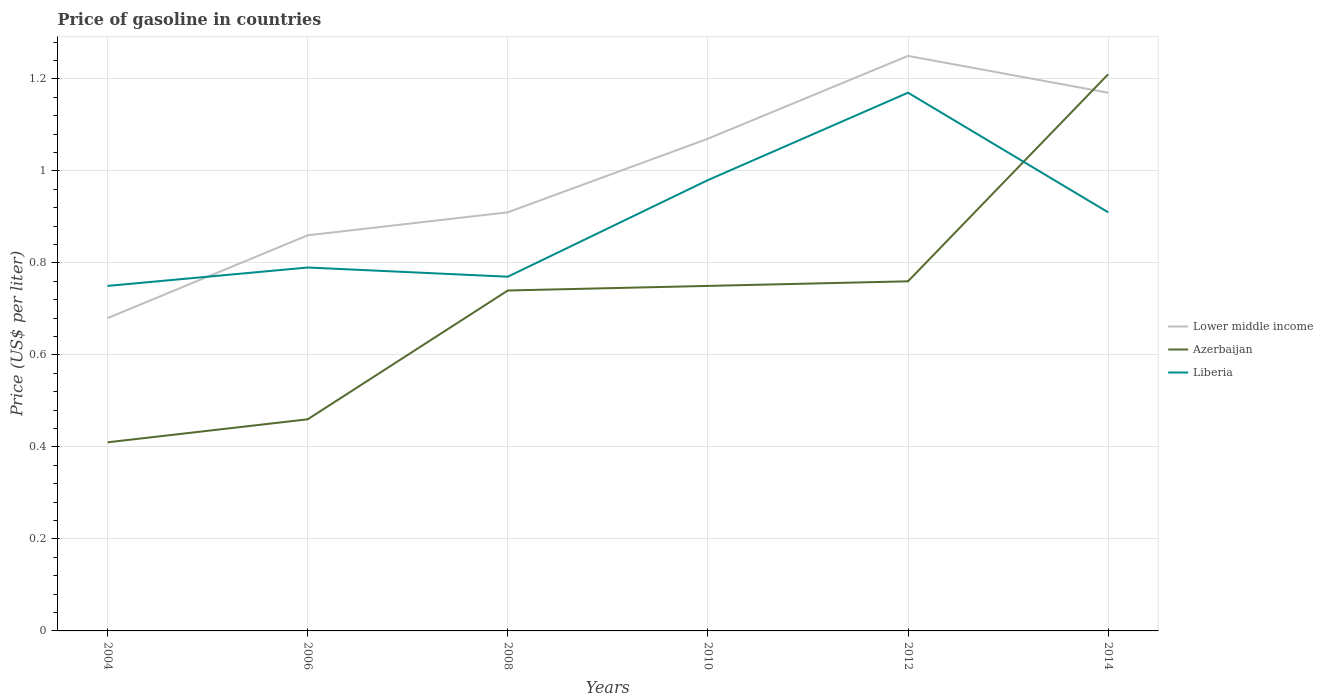Across all years, what is the maximum price of gasoline in Azerbaijan?
Offer a terse response. 0.41. What is the total price of gasoline in Lower middle income in the graph?
Make the answer very short. -0.1. What is the difference between the highest and the second highest price of gasoline in Lower middle income?
Your answer should be compact. 0.57. What is the difference between the highest and the lowest price of gasoline in Azerbaijan?
Make the answer very short. 4. Are the values on the major ticks of Y-axis written in scientific E-notation?
Your answer should be very brief. No. Does the graph contain any zero values?
Your answer should be compact. No. Does the graph contain grids?
Provide a short and direct response. Yes. Where does the legend appear in the graph?
Make the answer very short. Center right. How many legend labels are there?
Your answer should be compact. 3. How are the legend labels stacked?
Make the answer very short. Vertical. What is the title of the graph?
Your response must be concise. Price of gasoline in countries. What is the label or title of the Y-axis?
Offer a very short reply. Price (US$ per liter). What is the Price (US$ per liter) of Lower middle income in 2004?
Your response must be concise. 0.68. What is the Price (US$ per liter) in Azerbaijan in 2004?
Offer a terse response. 0.41. What is the Price (US$ per liter) in Liberia in 2004?
Your response must be concise. 0.75. What is the Price (US$ per liter) in Lower middle income in 2006?
Ensure brevity in your answer.  0.86. What is the Price (US$ per liter) of Azerbaijan in 2006?
Make the answer very short. 0.46. What is the Price (US$ per liter) of Liberia in 2006?
Offer a terse response. 0.79. What is the Price (US$ per liter) in Lower middle income in 2008?
Provide a succinct answer. 0.91. What is the Price (US$ per liter) of Azerbaijan in 2008?
Your answer should be very brief. 0.74. What is the Price (US$ per liter) in Liberia in 2008?
Your answer should be compact. 0.77. What is the Price (US$ per liter) in Lower middle income in 2010?
Provide a short and direct response. 1.07. What is the Price (US$ per liter) in Azerbaijan in 2010?
Provide a succinct answer. 0.75. What is the Price (US$ per liter) of Azerbaijan in 2012?
Provide a succinct answer. 0.76. What is the Price (US$ per liter) of Liberia in 2012?
Offer a terse response. 1.17. What is the Price (US$ per liter) of Lower middle income in 2014?
Keep it short and to the point. 1.17. What is the Price (US$ per liter) of Azerbaijan in 2014?
Offer a terse response. 1.21. What is the Price (US$ per liter) of Liberia in 2014?
Ensure brevity in your answer.  0.91. Across all years, what is the maximum Price (US$ per liter) in Lower middle income?
Give a very brief answer. 1.25. Across all years, what is the maximum Price (US$ per liter) of Azerbaijan?
Offer a terse response. 1.21. Across all years, what is the maximum Price (US$ per liter) of Liberia?
Your answer should be very brief. 1.17. Across all years, what is the minimum Price (US$ per liter) in Lower middle income?
Provide a succinct answer. 0.68. Across all years, what is the minimum Price (US$ per liter) in Azerbaijan?
Keep it short and to the point. 0.41. What is the total Price (US$ per liter) of Lower middle income in the graph?
Offer a terse response. 5.94. What is the total Price (US$ per liter) of Azerbaijan in the graph?
Provide a succinct answer. 4.33. What is the total Price (US$ per liter) in Liberia in the graph?
Your response must be concise. 5.37. What is the difference between the Price (US$ per liter) of Lower middle income in 2004 and that in 2006?
Your answer should be very brief. -0.18. What is the difference between the Price (US$ per liter) in Liberia in 2004 and that in 2006?
Your response must be concise. -0.04. What is the difference between the Price (US$ per liter) of Lower middle income in 2004 and that in 2008?
Provide a succinct answer. -0.23. What is the difference between the Price (US$ per liter) in Azerbaijan in 2004 and that in 2008?
Keep it short and to the point. -0.33. What is the difference between the Price (US$ per liter) in Liberia in 2004 and that in 2008?
Give a very brief answer. -0.02. What is the difference between the Price (US$ per liter) of Lower middle income in 2004 and that in 2010?
Your answer should be very brief. -0.39. What is the difference between the Price (US$ per liter) of Azerbaijan in 2004 and that in 2010?
Your answer should be compact. -0.34. What is the difference between the Price (US$ per liter) of Liberia in 2004 and that in 2010?
Your answer should be compact. -0.23. What is the difference between the Price (US$ per liter) of Lower middle income in 2004 and that in 2012?
Your response must be concise. -0.57. What is the difference between the Price (US$ per liter) in Azerbaijan in 2004 and that in 2012?
Offer a very short reply. -0.35. What is the difference between the Price (US$ per liter) in Liberia in 2004 and that in 2012?
Provide a succinct answer. -0.42. What is the difference between the Price (US$ per liter) of Lower middle income in 2004 and that in 2014?
Keep it short and to the point. -0.49. What is the difference between the Price (US$ per liter) in Azerbaijan in 2004 and that in 2014?
Provide a short and direct response. -0.8. What is the difference between the Price (US$ per liter) of Liberia in 2004 and that in 2014?
Your response must be concise. -0.16. What is the difference between the Price (US$ per liter) of Lower middle income in 2006 and that in 2008?
Provide a succinct answer. -0.05. What is the difference between the Price (US$ per liter) in Azerbaijan in 2006 and that in 2008?
Ensure brevity in your answer.  -0.28. What is the difference between the Price (US$ per liter) of Lower middle income in 2006 and that in 2010?
Your answer should be compact. -0.21. What is the difference between the Price (US$ per liter) of Azerbaijan in 2006 and that in 2010?
Your answer should be compact. -0.29. What is the difference between the Price (US$ per liter) in Liberia in 2006 and that in 2010?
Your answer should be very brief. -0.19. What is the difference between the Price (US$ per liter) of Lower middle income in 2006 and that in 2012?
Offer a very short reply. -0.39. What is the difference between the Price (US$ per liter) in Liberia in 2006 and that in 2012?
Ensure brevity in your answer.  -0.38. What is the difference between the Price (US$ per liter) of Lower middle income in 2006 and that in 2014?
Give a very brief answer. -0.31. What is the difference between the Price (US$ per liter) in Azerbaijan in 2006 and that in 2014?
Offer a very short reply. -0.75. What is the difference between the Price (US$ per liter) of Liberia in 2006 and that in 2014?
Provide a succinct answer. -0.12. What is the difference between the Price (US$ per liter) of Lower middle income in 2008 and that in 2010?
Your answer should be very brief. -0.16. What is the difference between the Price (US$ per liter) of Azerbaijan in 2008 and that in 2010?
Make the answer very short. -0.01. What is the difference between the Price (US$ per liter) in Liberia in 2008 and that in 2010?
Offer a very short reply. -0.21. What is the difference between the Price (US$ per liter) in Lower middle income in 2008 and that in 2012?
Provide a succinct answer. -0.34. What is the difference between the Price (US$ per liter) of Azerbaijan in 2008 and that in 2012?
Offer a terse response. -0.02. What is the difference between the Price (US$ per liter) in Liberia in 2008 and that in 2012?
Make the answer very short. -0.4. What is the difference between the Price (US$ per liter) in Lower middle income in 2008 and that in 2014?
Offer a terse response. -0.26. What is the difference between the Price (US$ per liter) in Azerbaijan in 2008 and that in 2014?
Your answer should be compact. -0.47. What is the difference between the Price (US$ per liter) in Liberia in 2008 and that in 2014?
Ensure brevity in your answer.  -0.14. What is the difference between the Price (US$ per liter) in Lower middle income in 2010 and that in 2012?
Offer a very short reply. -0.18. What is the difference between the Price (US$ per liter) in Azerbaijan in 2010 and that in 2012?
Offer a very short reply. -0.01. What is the difference between the Price (US$ per liter) in Liberia in 2010 and that in 2012?
Offer a terse response. -0.19. What is the difference between the Price (US$ per liter) in Azerbaijan in 2010 and that in 2014?
Offer a very short reply. -0.46. What is the difference between the Price (US$ per liter) of Liberia in 2010 and that in 2014?
Offer a very short reply. 0.07. What is the difference between the Price (US$ per liter) in Azerbaijan in 2012 and that in 2014?
Provide a short and direct response. -0.45. What is the difference between the Price (US$ per liter) in Liberia in 2012 and that in 2014?
Keep it short and to the point. 0.26. What is the difference between the Price (US$ per liter) of Lower middle income in 2004 and the Price (US$ per liter) of Azerbaijan in 2006?
Make the answer very short. 0.22. What is the difference between the Price (US$ per liter) in Lower middle income in 2004 and the Price (US$ per liter) in Liberia in 2006?
Make the answer very short. -0.11. What is the difference between the Price (US$ per liter) in Azerbaijan in 2004 and the Price (US$ per liter) in Liberia in 2006?
Your answer should be compact. -0.38. What is the difference between the Price (US$ per liter) of Lower middle income in 2004 and the Price (US$ per liter) of Azerbaijan in 2008?
Ensure brevity in your answer.  -0.06. What is the difference between the Price (US$ per liter) in Lower middle income in 2004 and the Price (US$ per liter) in Liberia in 2008?
Ensure brevity in your answer.  -0.09. What is the difference between the Price (US$ per liter) in Azerbaijan in 2004 and the Price (US$ per liter) in Liberia in 2008?
Give a very brief answer. -0.36. What is the difference between the Price (US$ per liter) in Lower middle income in 2004 and the Price (US$ per liter) in Azerbaijan in 2010?
Provide a short and direct response. -0.07. What is the difference between the Price (US$ per liter) in Azerbaijan in 2004 and the Price (US$ per liter) in Liberia in 2010?
Offer a very short reply. -0.57. What is the difference between the Price (US$ per liter) of Lower middle income in 2004 and the Price (US$ per liter) of Azerbaijan in 2012?
Your response must be concise. -0.08. What is the difference between the Price (US$ per liter) in Lower middle income in 2004 and the Price (US$ per liter) in Liberia in 2012?
Ensure brevity in your answer.  -0.49. What is the difference between the Price (US$ per liter) of Azerbaijan in 2004 and the Price (US$ per liter) of Liberia in 2012?
Provide a short and direct response. -0.76. What is the difference between the Price (US$ per liter) of Lower middle income in 2004 and the Price (US$ per liter) of Azerbaijan in 2014?
Keep it short and to the point. -0.53. What is the difference between the Price (US$ per liter) in Lower middle income in 2004 and the Price (US$ per liter) in Liberia in 2014?
Your answer should be very brief. -0.23. What is the difference between the Price (US$ per liter) in Lower middle income in 2006 and the Price (US$ per liter) in Azerbaijan in 2008?
Ensure brevity in your answer.  0.12. What is the difference between the Price (US$ per liter) of Lower middle income in 2006 and the Price (US$ per liter) of Liberia in 2008?
Give a very brief answer. 0.09. What is the difference between the Price (US$ per liter) in Azerbaijan in 2006 and the Price (US$ per liter) in Liberia in 2008?
Provide a short and direct response. -0.31. What is the difference between the Price (US$ per liter) in Lower middle income in 2006 and the Price (US$ per liter) in Azerbaijan in 2010?
Make the answer very short. 0.11. What is the difference between the Price (US$ per liter) in Lower middle income in 2006 and the Price (US$ per liter) in Liberia in 2010?
Your answer should be compact. -0.12. What is the difference between the Price (US$ per liter) in Azerbaijan in 2006 and the Price (US$ per liter) in Liberia in 2010?
Offer a very short reply. -0.52. What is the difference between the Price (US$ per liter) in Lower middle income in 2006 and the Price (US$ per liter) in Liberia in 2012?
Your answer should be compact. -0.31. What is the difference between the Price (US$ per liter) of Azerbaijan in 2006 and the Price (US$ per liter) of Liberia in 2012?
Provide a short and direct response. -0.71. What is the difference between the Price (US$ per liter) in Lower middle income in 2006 and the Price (US$ per liter) in Azerbaijan in 2014?
Provide a succinct answer. -0.35. What is the difference between the Price (US$ per liter) in Azerbaijan in 2006 and the Price (US$ per liter) in Liberia in 2014?
Provide a short and direct response. -0.45. What is the difference between the Price (US$ per liter) of Lower middle income in 2008 and the Price (US$ per liter) of Azerbaijan in 2010?
Offer a terse response. 0.16. What is the difference between the Price (US$ per liter) in Lower middle income in 2008 and the Price (US$ per liter) in Liberia in 2010?
Ensure brevity in your answer.  -0.07. What is the difference between the Price (US$ per liter) in Azerbaijan in 2008 and the Price (US$ per liter) in Liberia in 2010?
Keep it short and to the point. -0.24. What is the difference between the Price (US$ per liter) of Lower middle income in 2008 and the Price (US$ per liter) of Azerbaijan in 2012?
Your response must be concise. 0.15. What is the difference between the Price (US$ per liter) of Lower middle income in 2008 and the Price (US$ per liter) of Liberia in 2012?
Your response must be concise. -0.26. What is the difference between the Price (US$ per liter) of Azerbaijan in 2008 and the Price (US$ per liter) of Liberia in 2012?
Your answer should be very brief. -0.43. What is the difference between the Price (US$ per liter) of Azerbaijan in 2008 and the Price (US$ per liter) of Liberia in 2014?
Your answer should be compact. -0.17. What is the difference between the Price (US$ per liter) in Lower middle income in 2010 and the Price (US$ per liter) in Azerbaijan in 2012?
Offer a terse response. 0.31. What is the difference between the Price (US$ per liter) of Azerbaijan in 2010 and the Price (US$ per liter) of Liberia in 2012?
Provide a succinct answer. -0.42. What is the difference between the Price (US$ per liter) of Lower middle income in 2010 and the Price (US$ per liter) of Azerbaijan in 2014?
Offer a very short reply. -0.14. What is the difference between the Price (US$ per liter) of Lower middle income in 2010 and the Price (US$ per liter) of Liberia in 2014?
Give a very brief answer. 0.16. What is the difference between the Price (US$ per liter) in Azerbaijan in 2010 and the Price (US$ per liter) in Liberia in 2014?
Your answer should be compact. -0.16. What is the difference between the Price (US$ per liter) in Lower middle income in 2012 and the Price (US$ per liter) in Azerbaijan in 2014?
Offer a very short reply. 0.04. What is the difference between the Price (US$ per liter) of Lower middle income in 2012 and the Price (US$ per liter) of Liberia in 2014?
Keep it short and to the point. 0.34. What is the average Price (US$ per liter) of Lower middle income per year?
Give a very brief answer. 0.99. What is the average Price (US$ per liter) of Azerbaijan per year?
Offer a terse response. 0.72. What is the average Price (US$ per liter) in Liberia per year?
Provide a short and direct response. 0.9. In the year 2004, what is the difference between the Price (US$ per liter) in Lower middle income and Price (US$ per liter) in Azerbaijan?
Ensure brevity in your answer.  0.27. In the year 2004, what is the difference between the Price (US$ per liter) of Lower middle income and Price (US$ per liter) of Liberia?
Provide a succinct answer. -0.07. In the year 2004, what is the difference between the Price (US$ per liter) of Azerbaijan and Price (US$ per liter) of Liberia?
Give a very brief answer. -0.34. In the year 2006, what is the difference between the Price (US$ per liter) in Lower middle income and Price (US$ per liter) in Azerbaijan?
Offer a very short reply. 0.4. In the year 2006, what is the difference between the Price (US$ per liter) in Lower middle income and Price (US$ per liter) in Liberia?
Ensure brevity in your answer.  0.07. In the year 2006, what is the difference between the Price (US$ per liter) in Azerbaijan and Price (US$ per liter) in Liberia?
Keep it short and to the point. -0.33. In the year 2008, what is the difference between the Price (US$ per liter) of Lower middle income and Price (US$ per liter) of Azerbaijan?
Your answer should be very brief. 0.17. In the year 2008, what is the difference between the Price (US$ per liter) in Lower middle income and Price (US$ per liter) in Liberia?
Offer a terse response. 0.14. In the year 2008, what is the difference between the Price (US$ per liter) of Azerbaijan and Price (US$ per liter) of Liberia?
Offer a terse response. -0.03. In the year 2010, what is the difference between the Price (US$ per liter) in Lower middle income and Price (US$ per liter) in Azerbaijan?
Make the answer very short. 0.32. In the year 2010, what is the difference between the Price (US$ per liter) in Lower middle income and Price (US$ per liter) in Liberia?
Keep it short and to the point. 0.09. In the year 2010, what is the difference between the Price (US$ per liter) of Azerbaijan and Price (US$ per liter) of Liberia?
Provide a short and direct response. -0.23. In the year 2012, what is the difference between the Price (US$ per liter) of Lower middle income and Price (US$ per liter) of Azerbaijan?
Your response must be concise. 0.49. In the year 2012, what is the difference between the Price (US$ per liter) of Azerbaijan and Price (US$ per liter) of Liberia?
Make the answer very short. -0.41. In the year 2014, what is the difference between the Price (US$ per liter) in Lower middle income and Price (US$ per liter) in Azerbaijan?
Offer a very short reply. -0.04. In the year 2014, what is the difference between the Price (US$ per liter) of Lower middle income and Price (US$ per liter) of Liberia?
Your answer should be very brief. 0.26. What is the ratio of the Price (US$ per liter) of Lower middle income in 2004 to that in 2006?
Offer a terse response. 0.79. What is the ratio of the Price (US$ per liter) of Azerbaijan in 2004 to that in 2006?
Your response must be concise. 0.89. What is the ratio of the Price (US$ per liter) in Liberia in 2004 to that in 2006?
Your answer should be very brief. 0.95. What is the ratio of the Price (US$ per liter) in Lower middle income in 2004 to that in 2008?
Keep it short and to the point. 0.75. What is the ratio of the Price (US$ per liter) in Azerbaijan in 2004 to that in 2008?
Provide a succinct answer. 0.55. What is the ratio of the Price (US$ per liter) of Liberia in 2004 to that in 2008?
Provide a succinct answer. 0.97. What is the ratio of the Price (US$ per liter) of Lower middle income in 2004 to that in 2010?
Ensure brevity in your answer.  0.64. What is the ratio of the Price (US$ per liter) in Azerbaijan in 2004 to that in 2010?
Keep it short and to the point. 0.55. What is the ratio of the Price (US$ per liter) of Liberia in 2004 to that in 2010?
Keep it short and to the point. 0.77. What is the ratio of the Price (US$ per liter) of Lower middle income in 2004 to that in 2012?
Give a very brief answer. 0.54. What is the ratio of the Price (US$ per liter) of Azerbaijan in 2004 to that in 2012?
Ensure brevity in your answer.  0.54. What is the ratio of the Price (US$ per liter) in Liberia in 2004 to that in 2012?
Your response must be concise. 0.64. What is the ratio of the Price (US$ per liter) of Lower middle income in 2004 to that in 2014?
Give a very brief answer. 0.58. What is the ratio of the Price (US$ per liter) in Azerbaijan in 2004 to that in 2014?
Give a very brief answer. 0.34. What is the ratio of the Price (US$ per liter) of Liberia in 2004 to that in 2014?
Keep it short and to the point. 0.82. What is the ratio of the Price (US$ per liter) in Lower middle income in 2006 to that in 2008?
Keep it short and to the point. 0.95. What is the ratio of the Price (US$ per liter) of Azerbaijan in 2006 to that in 2008?
Make the answer very short. 0.62. What is the ratio of the Price (US$ per liter) of Lower middle income in 2006 to that in 2010?
Your response must be concise. 0.8. What is the ratio of the Price (US$ per liter) in Azerbaijan in 2006 to that in 2010?
Give a very brief answer. 0.61. What is the ratio of the Price (US$ per liter) of Liberia in 2006 to that in 2010?
Provide a succinct answer. 0.81. What is the ratio of the Price (US$ per liter) of Lower middle income in 2006 to that in 2012?
Provide a succinct answer. 0.69. What is the ratio of the Price (US$ per liter) of Azerbaijan in 2006 to that in 2012?
Your answer should be compact. 0.61. What is the ratio of the Price (US$ per liter) in Liberia in 2006 to that in 2012?
Offer a very short reply. 0.68. What is the ratio of the Price (US$ per liter) of Lower middle income in 2006 to that in 2014?
Make the answer very short. 0.73. What is the ratio of the Price (US$ per liter) of Azerbaijan in 2006 to that in 2014?
Provide a short and direct response. 0.38. What is the ratio of the Price (US$ per liter) of Liberia in 2006 to that in 2014?
Provide a short and direct response. 0.87. What is the ratio of the Price (US$ per liter) in Lower middle income in 2008 to that in 2010?
Offer a very short reply. 0.85. What is the ratio of the Price (US$ per liter) of Azerbaijan in 2008 to that in 2010?
Your response must be concise. 0.99. What is the ratio of the Price (US$ per liter) in Liberia in 2008 to that in 2010?
Keep it short and to the point. 0.79. What is the ratio of the Price (US$ per liter) of Lower middle income in 2008 to that in 2012?
Your response must be concise. 0.73. What is the ratio of the Price (US$ per liter) in Azerbaijan in 2008 to that in 2012?
Provide a succinct answer. 0.97. What is the ratio of the Price (US$ per liter) in Liberia in 2008 to that in 2012?
Offer a terse response. 0.66. What is the ratio of the Price (US$ per liter) of Lower middle income in 2008 to that in 2014?
Your answer should be compact. 0.78. What is the ratio of the Price (US$ per liter) in Azerbaijan in 2008 to that in 2014?
Make the answer very short. 0.61. What is the ratio of the Price (US$ per liter) of Liberia in 2008 to that in 2014?
Your response must be concise. 0.85. What is the ratio of the Price (US$ per liter) of Lower middle income in 2010 to that in 2012?
Offer a terse response. 0.86. What is the ratio of the Price (US$ per liter) of Azerbaijan in 2010 to that in 2012?
Provide a short and direct response. 0.99. What is the ratio of the Price (US$ per liter) of Liberia in 2010 to that in 2012?
Offer a very short reply. 0.84. What is the ratio of the Price (US$ per liter) in Lower middle income in 2010 to that in 2014?
Provide a succinct answer. 0.91. What is the ratio of the Price (US$ per liter) in Azerbaijan in 2010 to that in 2014?
Offer a terse response. 0.62. What is the ratio of the Price (US$ per liter) of Lower middle income in 2012 to that in 2014?
Ensure brevity in your answer.  1.07. What is the ratio of the Price (US$ per liter) of Azerbaijan in 2012 to that in 2014?
Offer a terse response. 0.63. What is the difference between the highest and the second highest Price (US$ per liter) in Lower middle income?
Your answer should be compact. 0.08. What is the difference between the highest and the second highest Price (US$ per liter) of Azerbaijan?
Offer a very short reply. 0.45. What is the difference between the highest and the second highest Price (US$ per liter) of Liberia?
Ensure brevity in your answer.  0.19. What is the difference between the highest and the lowest Price (US$ per liter) of Lower middle income?
Make the answer very short. 0.57. What is the difference between the highest and the lowest Price (US$ per liter) of Liberia?
Provide a short and direct response. 0.42. 